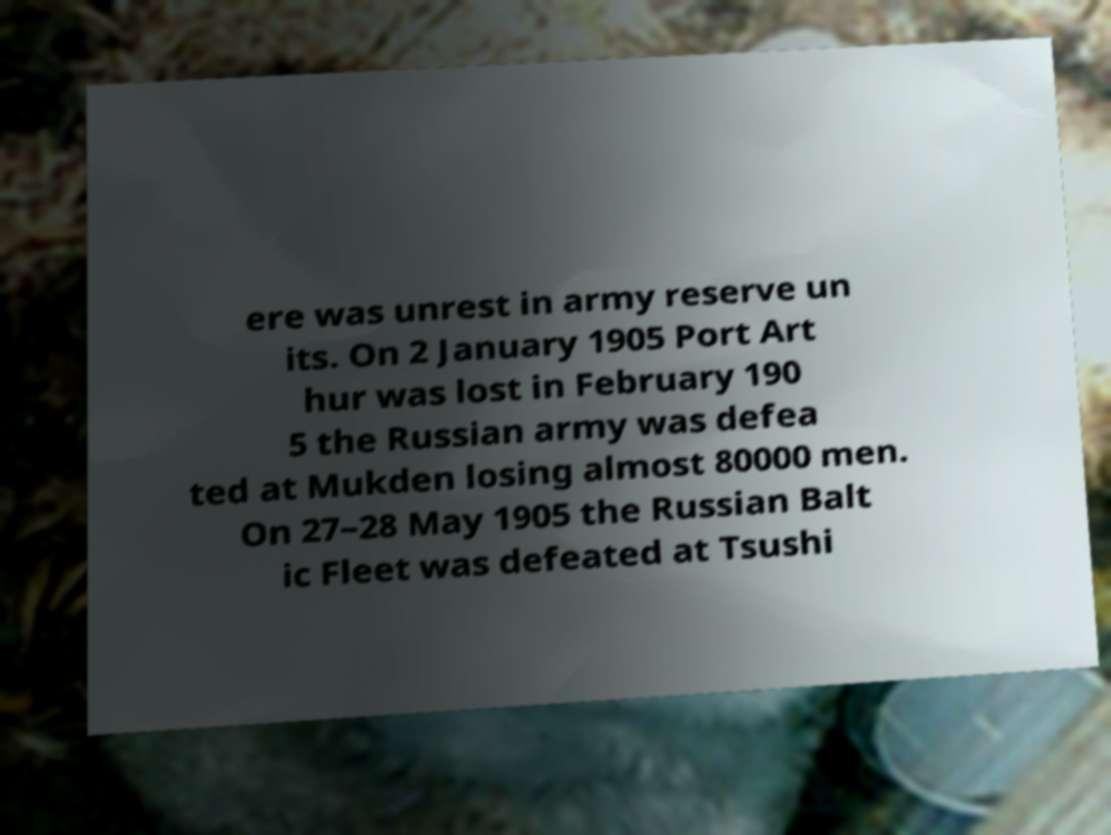Could you extract and type out the text from this image? ere was unrest in army reserve un its. On 2 January 1905 Port Art hur was lost in February 190 5 the Russian army was defea ted at Mukden losing almost 80000 men. On 27–28 May 1905 the Russian Balt ic Fleet was defeated at Tsushi 